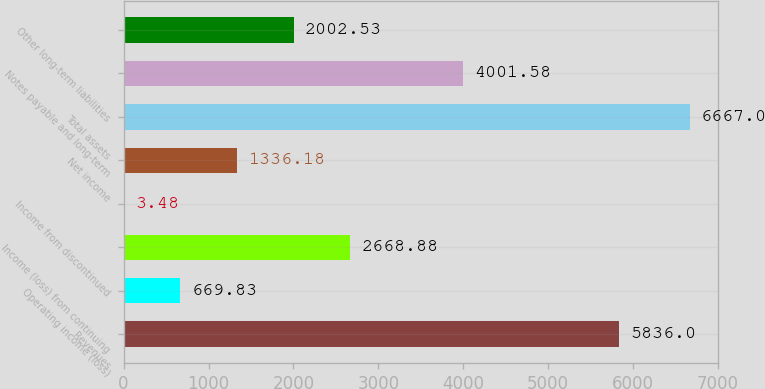<chart> <loc_0><loc_0><loc_500><loc_500><bar_chart><fcel>Revenues<fcel>Operating income (loss)<fcel>Income (loss) from continuing<fcel>Income from discontinued<fcel>Net income<fcel>Total assets<fcel>Notes payable and long-term<fcel>Other long-term liabilities<nl><fcel>5836<fcel>669.83<fcel>2668.88<fcel>3.48<fcel>1336.18<fcel>6667<fcel>4001.58<fcel>2002.53<nl></chart> 